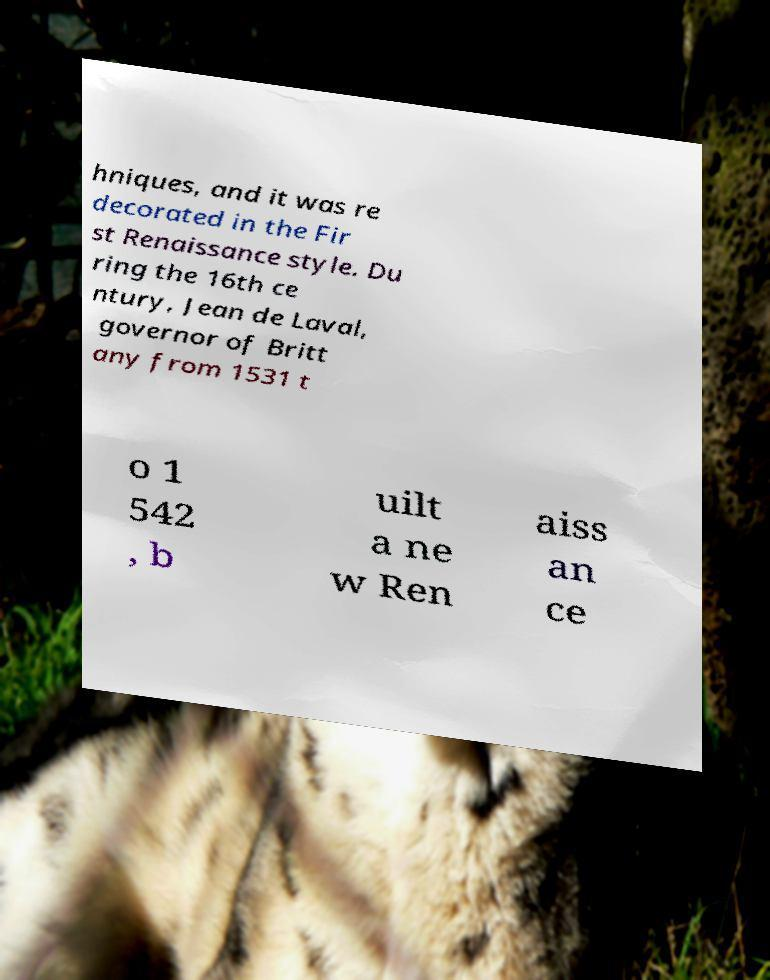Please identify and transcribe the text found in this image. hniques, and it was re decorated in the Fir st Renaissance style. Du ring the 16th ce ntury, Jean de Laval, governor of Britt any from 1531 t o 1 542 , b uilt a ne w Ren aiss an ce 